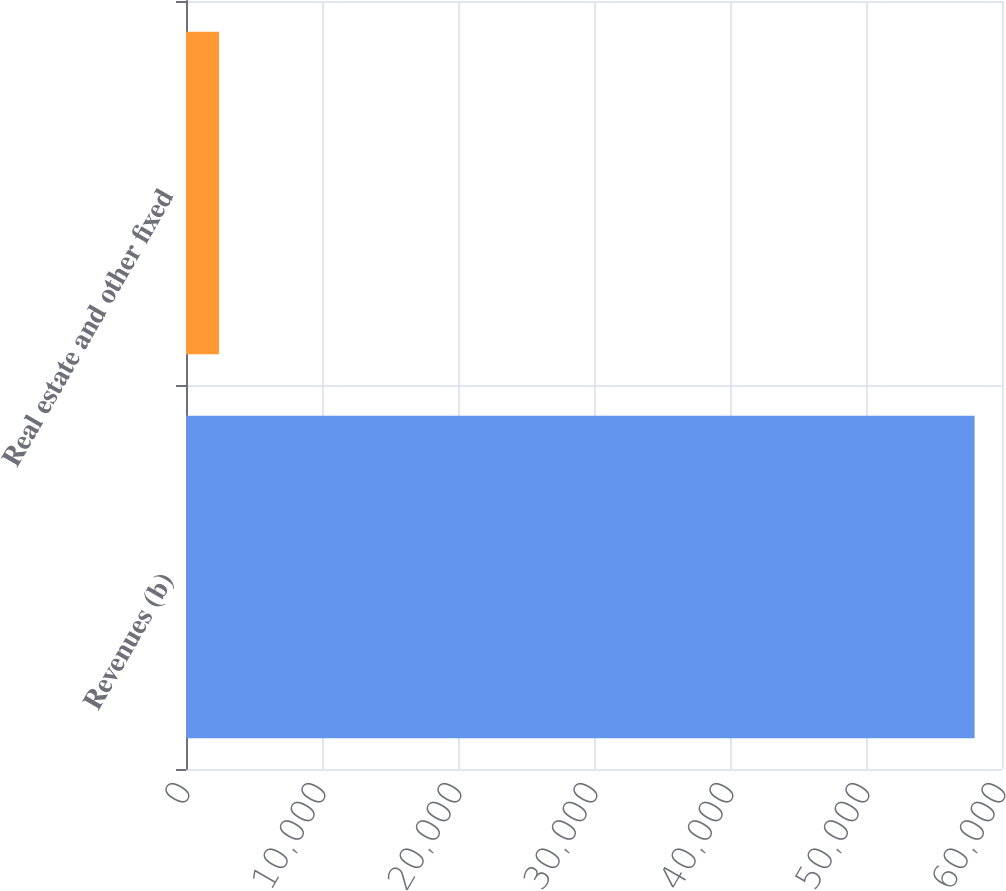Convert chart. <chart><loc_0><loc_0><loc_500><loc_500><bar_chart><fcel>Revenues (b)<fcel>Real estate and other fixed<nl><fcel>57986<fcel>2432<nl></chart> 